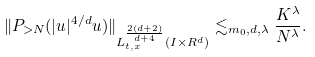<formula> <loc_0><loc_0><loc_500><loc_500>\| P _ { > N } ( | u | ^ { 4 / d } u ) \| _ { L _ { t , x } ^ { \frac { 2 ( d + 2 ) } { d + 4 } } ( I \times R ^ { d } ) } \lesssim _ { m _ { 0 } , d , \lambda } \frac { K ^ { \lambda } } { N ^ { \lambda } } .</formula> 